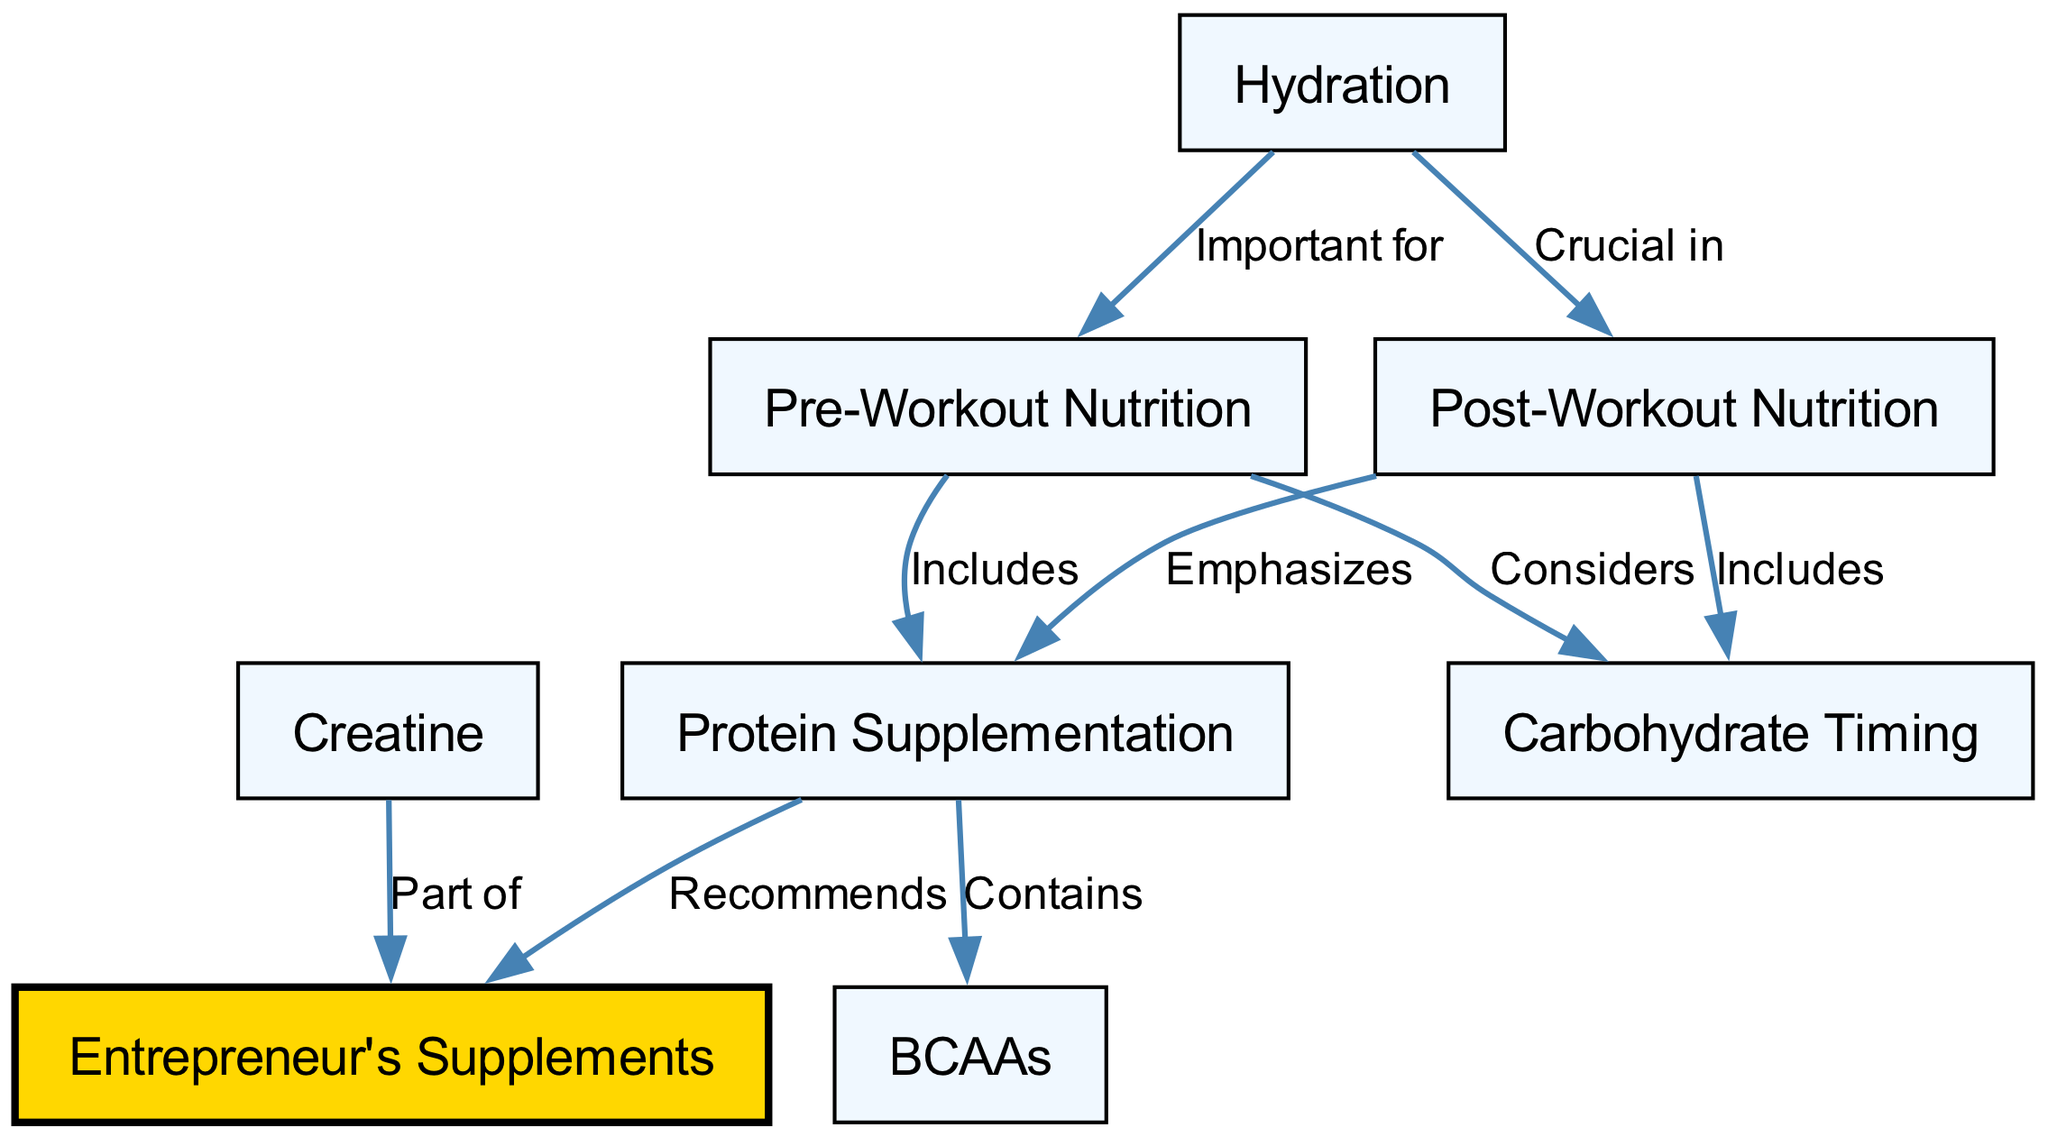What are the main aspects of Pre-Workout Nutrition? The Pre-Workout Nutrition node connects to the Protein Supplementation and Carbohydrate Timing nodes, indicating that these elements are included or considered as part of pre-workout planning.
Answer: Protein Supplementation and Carbohydrate Timing Which two aspects are emphasized in Post-Workout Nutrition? The Post-Workout Nutrition node connects to the Protein Supplementation and Carbohydrate Timing nodes, suggesting these are key components to consider after workouts.
Answer: Protein Supplementation and Carbohydrate Timing What does Protein Supplementation contain? The Protein Supplementation node has a direct link to the BCAAs node with the label "Contains," indicating that BCAAs are a part of protein supplementation.
Answer: BCAAs How many nodes are in the diagram? By counting the unique entries listed in the nodes section, we determine there are eight distinct components relevant to nutrient timing and supplementation in the diagram.
Answer: Eight What is the significance of Hydration in relation to Pre-Workout and Post-Workout Nutrition? The Hydration node connects to both the Pre-Workout Nutrition and Post-Workout Nutrition nodes. This indicates that hydration is important before and crucial after workout sessions, emphasizing its supportive role in both contexts.
Answer: Important for and Crucial in Which Supplement is recommended under Protein Supplementation? The Protein Supplementation node is linked to the Entrepreneur's Supplements node with the label "Recommends," indicating that this particular supplement is suggested for optimal nutrition around protein intake.
Answer: Entrepreneur's Supplements What is Creatine classified as in this concept map? The diagram shows that Creatine is directly linked to the Entrepreneur's Supplements node with the label "Part of," indicating that it is included as one of the components recommended for supplementation.
Answer: Part of What relationships can be observed between Post-Workout Nutrition and Protein Supplementation? The edge from Post-Workout Nutrition to Protein Supplementation labeled "Emphasizes" shows that post-workout nutrition specifically highlights the importance of protein supplements for recovery.
Answer: Emphasizes Which two nutritional aspects are showed to be significant before exercising? The Pre-Workout Nutrition node shows connections to Protein Supplementation and Carbohydrate Timing, indicating that both are key nutritional focus areas before exercise.
Answer: Protein Supplementation and Carbohydrate Timing 